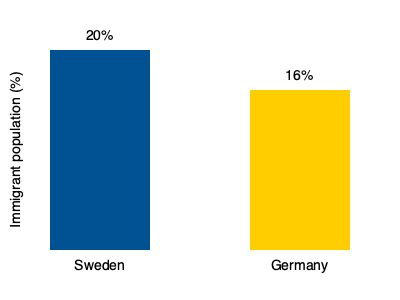Based on the bar graph comparing immigrant population percentages in Sweden and Germany, how many percentage points higher is Sweden's immigrant population compared to Germany's? To find the difference in percentage points between Sweden's and Germany's immigrant populations, we need to:

1. Identify Sweden's immigrant population percentage: 20%
2. Identify Germany's immigrant population percentage: 16%
3. Subtract Germany's percentage from Sweden's:
   $20\% - 16\% = 4\%$

The difference between the two percentages is 4 percentage points.

It's important to note that as an immigrant in Sweden interested in immigration politics, this information could be valuable for understanding the comparative scale of immigration in both countries and how it might influence policies and social dynamics.
Answer: 4 percentage points 